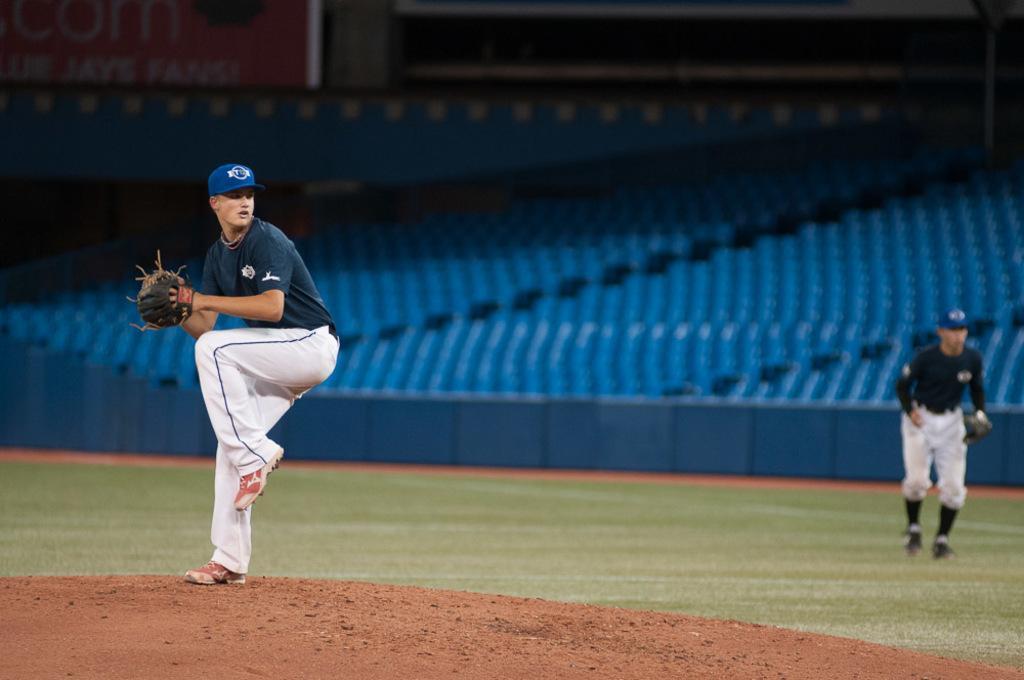How would you summarize this image in a sentence or two? In this image there are two men standing on the ground. They are wearing caps and catcher gloves. There is grass on the ground. Behind them there are seats. In the top left there is text on the board. 